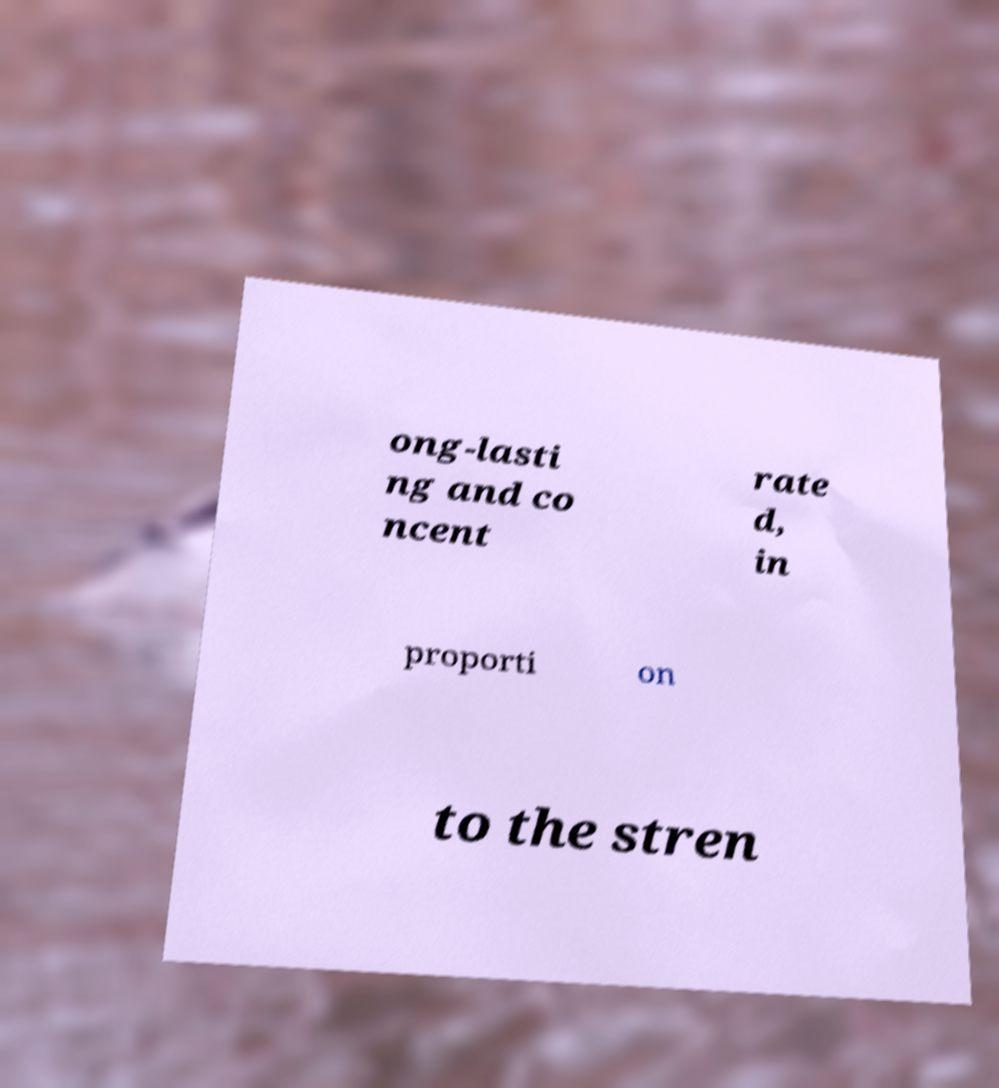Could you extract and type out the text from this image? ong-lasti ng and co ncent rate d, in proporti on to the stren 